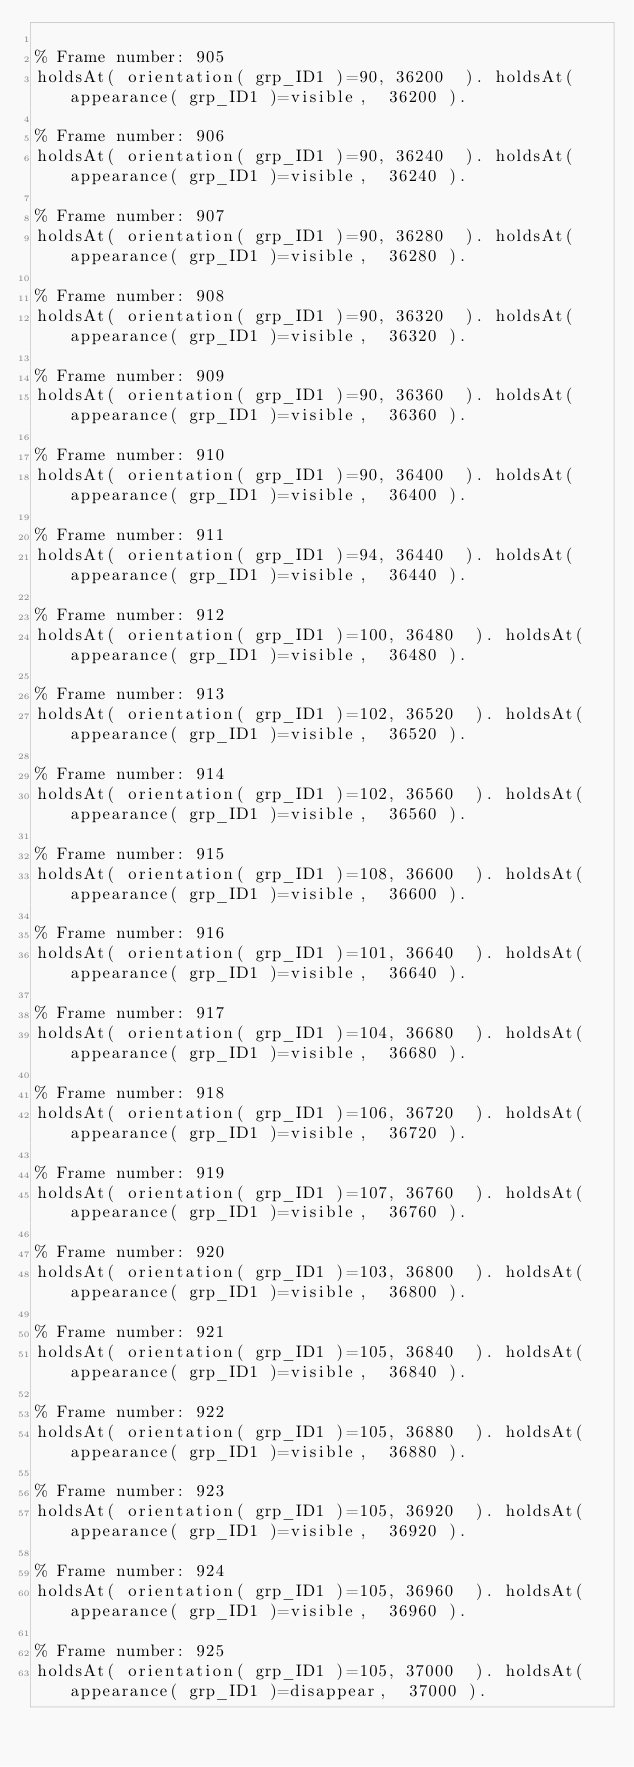<code> <loc_0><loc_0><loc_500><loc_500><_Perl_>
% Frame number: 905
holdsAt( orientation( grp_ID1 )=90, 36200  ). holdsAt( appearance( grp_ID1 )=visible,  36200 ).

% Frame number: 906
holdsAt( orientation( grp_ID1 )=90, 36240  ). holdsAt( appearance( grp_ID1 )=visible,  36240 ).

% Frame number: 907
holdsAt( orientation( grp_ID1 )=90, 36280  ). holdsAt( appearance( grp_ID1 )=visible,  36280 ).

% Frame number: 908
holdsAt( orientation( grp_ID1 )=90, 36320  ). holdsAt( appearance( grp_ID1 )=visible,  36320 ).

% Frame number: 909
holdsAt( orientation( grp_ID1 )=90, 36360  ). holdsAt( appearance( grp_ID1 )=visible,  36360 ).

% Frame number: 910
holdsAt( orientation( grp_ID1 )=90, 36400  ). holdsAt( appearance( grp_ID1 )=visible,  36400 ).

% Frame number: 911
holdsAt( orientation( grp_ID1 )=94, 36440  ). holdsAt( appearance( grp_ID1 )=visible,  36440 ).

% Frame number: 912
holdsAt( orientation( grp_ID1 )=100, 36480  ). holdsAt( appearance( grp_ID1 )=visible,  36480 ).

% Frame number: 913
holdsAt( orientation( grp_ID1 )=102, 36520  ). holdsAt( appearance( grp_ID1 )=visible,  36520 ).

% Frame number: 914
holdsAt( orientation( grp_ID1 )=102, 36560  ). holdsAt( appearance( grp_ID1 )=visible,  36560 ).

% Frame number: 915
holdsAt( orientation( grp_ID1 )=108, 36600  ). holdsAt( appearance( grp_ID1 )=visible,  36600 ).

% Frame number: 916
holdsAt( orientation( grp_ID1 )=101, 36640  ). holdsAt( appearance( grp_ID1 )=visible,  36640 ).

% Frame number: 917
holdsAt( orientation( grp_ID1 )=104, 36680  ). holdsAt( appearance( grp_ID1 )=visible,  36680 ).

% Frame number: 918
holdsAt( orientation( grp_ID1 )=106, 36720  ). holdsAt( appearance( grp_ID1 )=visible,  36720 ).

% Frame number: 919
holdsAt( orientation( grp_ID1 )=107, 36760  ). holdsAt( appearance( grp_ID1 )=visible,  36760 ).

% Frame number: 920
holdsAt( orientation( grp_ID1 )=103, 36800  ). holdsAt( appearance( grp_ID1 )=visible,  36800 ).

% Frame number: 921
holdsAt( orientation( grp_ID1 )=105, 36840  ). holdsAt( appearance( grp_ID1 )=visible,  36840 ).

% Frame number: 922
holdsAt( orientation( grp_ID1 )=105, 36880  ). holdsAt( appearance( grp_ID1 )=visible,  36880 ).

% Frame number: 923
holdsAt( orientation( grp_ID1 )=105, 36920  ). holdsAt( appearance( grp_ID1 )=visible,  36920 ).

% Frame number: 924
holdsAt( orientation( grp_ID1 )=105, 36960  ). holdsAt( appearance( grp_ID1 )=visible,  36960 ).

% Frame number: 925
holdsAt( orientation( grp_ID1 )=105, 37000  ). holdsAt( appearance( grp_ID1 )=disappear,  37000 ).

</code> 